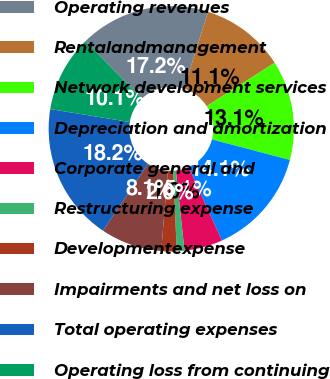<chart> <loc_0><loc_0><loc_500><loc_500><pie_chart><fcel>Operating revenues<fcel>Rentalandmanagement<fcel>Network development services<fcel>Depreciation and amortization<fcel>Corporate general and<fcel>Restructuring expense<fcel>Developmentexpense<fcel>Impairments and net loss on<fcel>Total operating expenses<fcel>Operating loss from continuing<nl><fcel>17.17%<fcel>11.11%<fcel>13.13%<fcel>14.14%<fcel>5.05%<fcel>1.01%<fcel>2.02%<fcel>8.08%<fcel>18.18%<fcel>10.1%<nl></chart> 